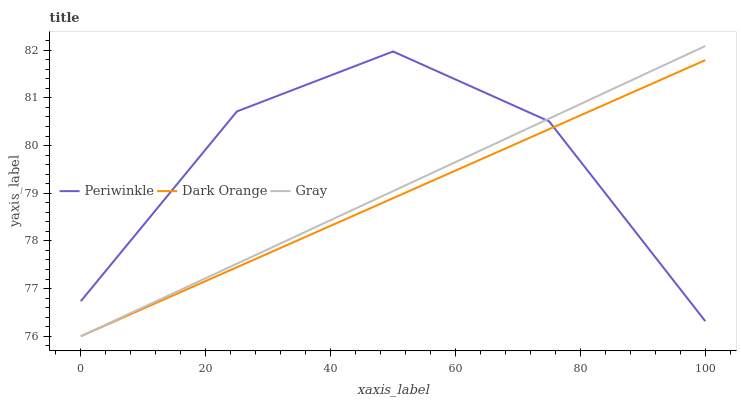Does Dark Orange have the minimum area under the curve?
Answer yes or no. Yes. Does Periwinkle have the maximum area under the curve?
Answer yes or no. Yes. Does Gray have the minimum area under the curve?
Answer yes or no. No. Does Gray have the maximum area under the curve?
Answer yes or no. No. Is Dark Orange the smoothest?
Answer yes or no. Yes. Is Periwinkle the roughest?
Answer yes or no. Yes. Is Gray the smoothest?
Answer yes or no. No. Is Gray the roughest?
Answer yes or no. No. Does Dark Orange have the lowest value?
Answer yes or no. Yes. Does Periwinkle have the lowest value?
Answer yes or no. No. Does Gray have the highest value?
Answer yes or no. Yes. Does Periwinkle have the highest value?
Answer yes or no. No. Does Dark Orange intersect Periwinkle?
Answer yes or no. Yes. Is Dark Orange less than Periwinkle?
Answer yes or no. No. Is Dark Orange greater than Periwinkle?
Answer yes or no. No. 